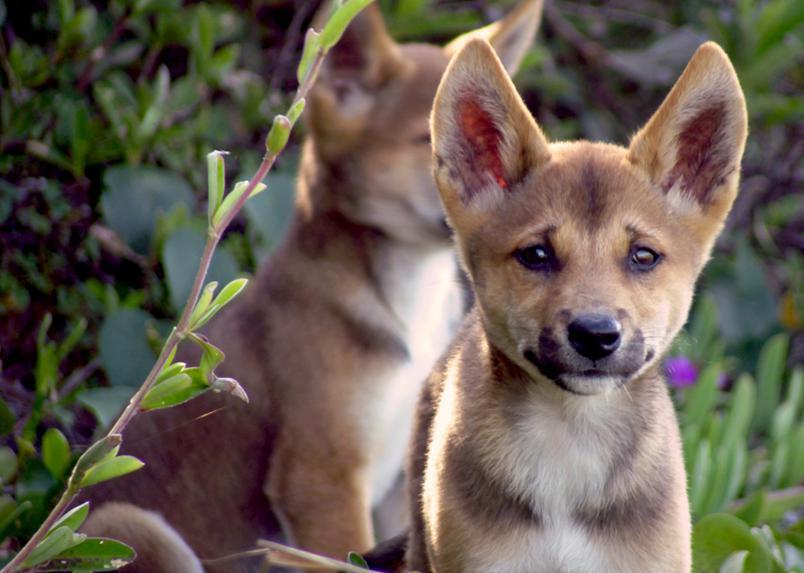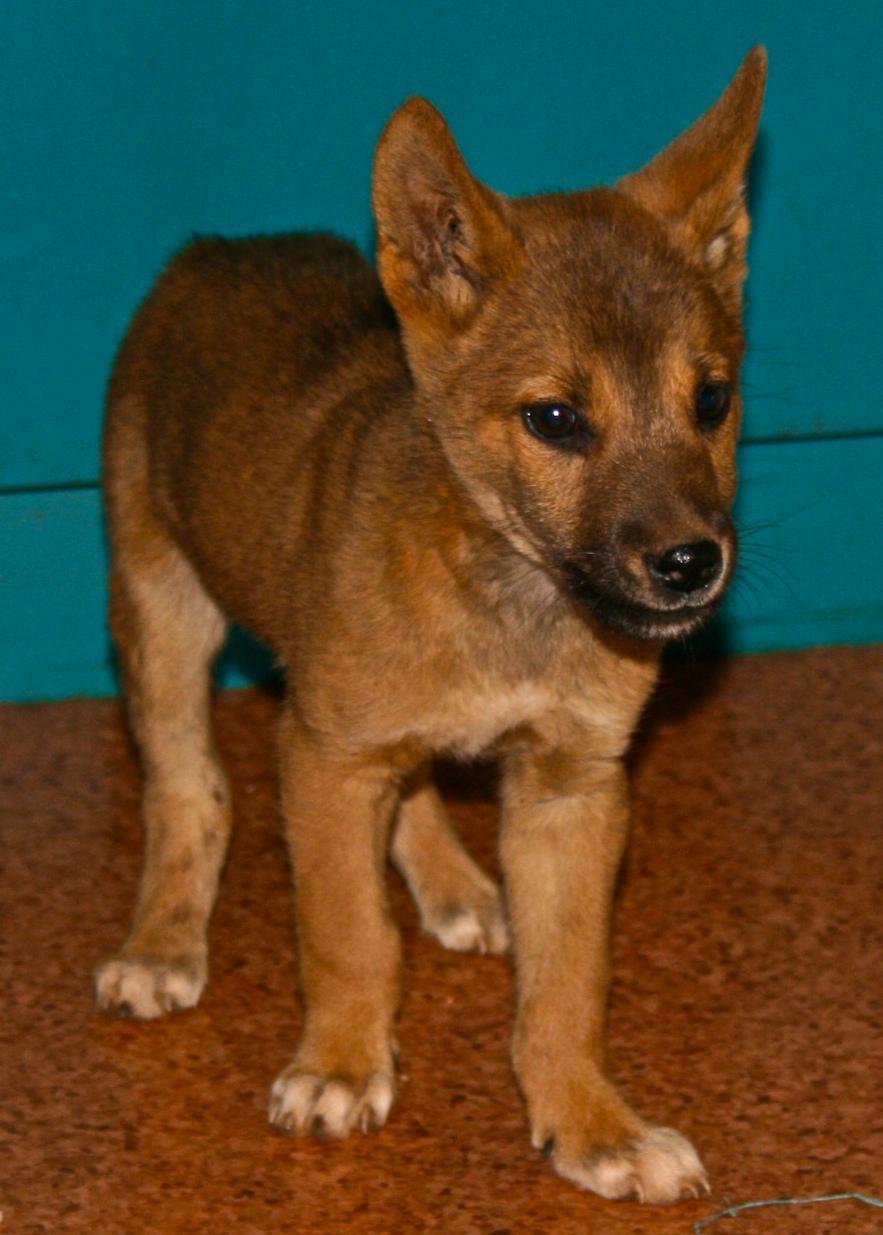The first image is the image on the left, the second image is the image on the right. For the images shown, is this caption "Two dingo pups are overlapping in the left image, with the dingo pup in front facing the camera." true? Answer yes or no. Yes. The first image is the image on the left, the second image is the image on the right. Evaluate the accuracy of this statement regarding the images: "Every photo shows exactly one dog and all dogs are photographed outside, but the dog on the right has a visible leash attached to its collar.". Is it true? Answer yes or no. No. 